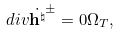Convert formula to latex. <formula><loc_0><loc_0><loc_500><loc_500>d i v \dot { \mathbf h ^ { \natural } } ^ { \pm } = 0 \Omega _ { T } ,</formula> 